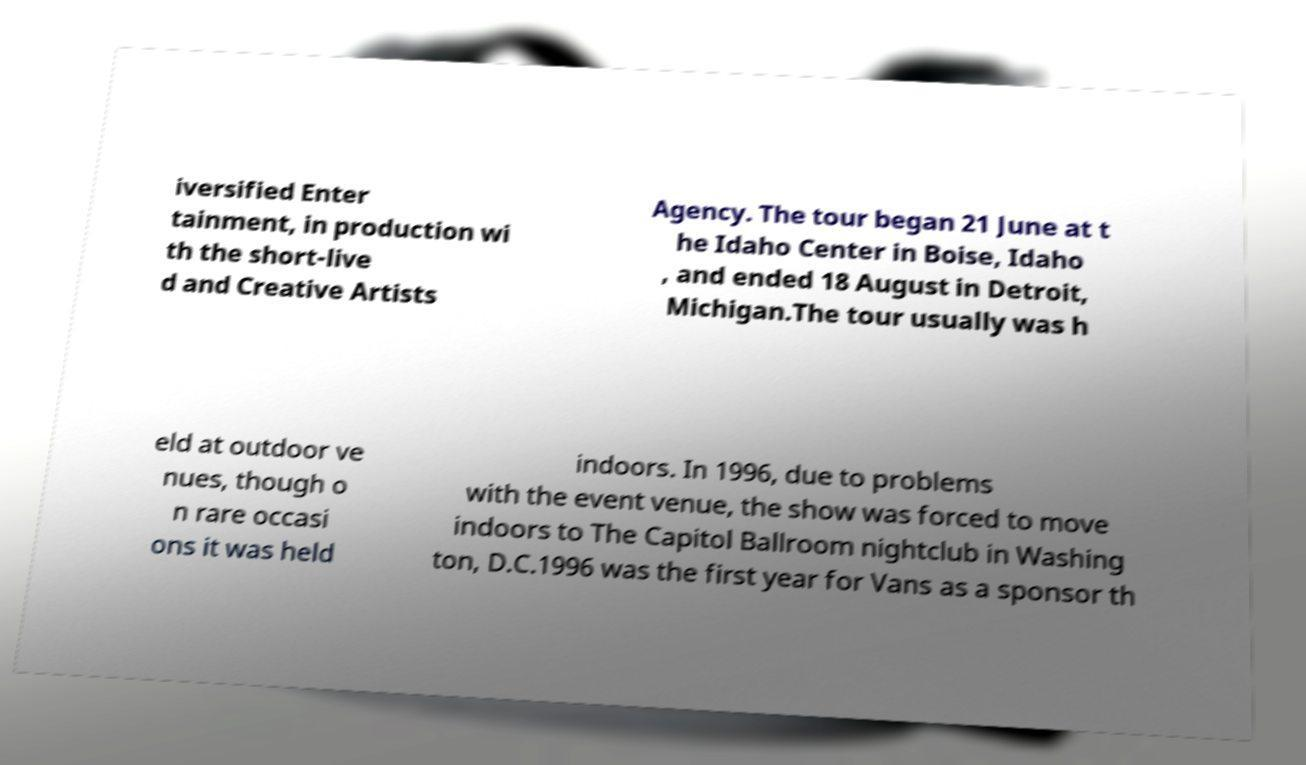There's text embedded in this image that I need extracted. Can you transcribe it verbatim? iversified Enter tainment, in production wi th the short-live d and Creative Artists Agency. The tour began 21 June at t he Idaho Center in Boise, Idaho , and ended 18 August in Detroit, Michigan.The tour usually was h eld at outdoor ve nues, though o n rare occasi ons it was held indoors. In 1996, due to problems with the event venue, the show was forced to move indoors to The Capitol Ballroom nightclub in Washing ton, D.C.1996 was the first year for Vans as a sponsor th 